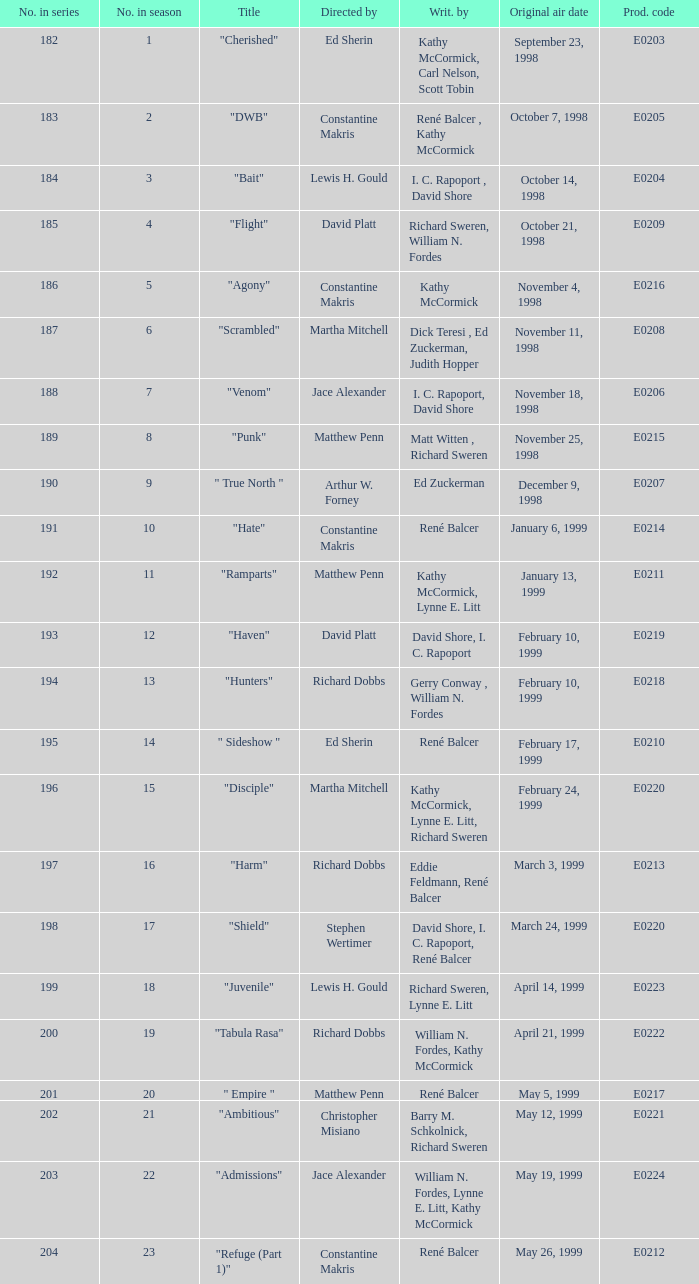What is the title of the episode with the original air date October 21, 1998? "Flight". 